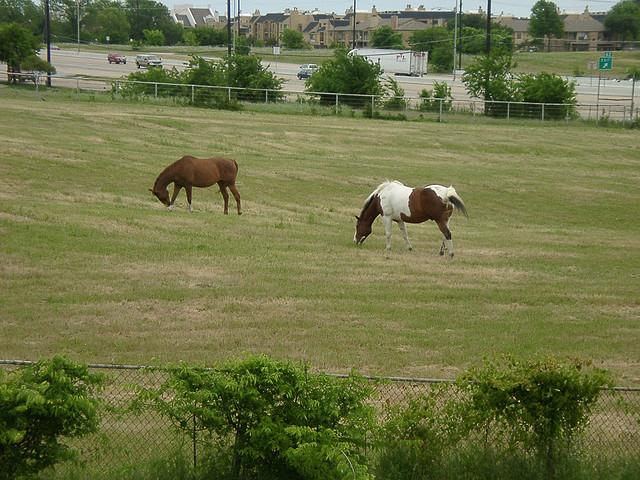Are there ducks here?
Keep it brief. No. What color is the smaller animal in the picture?
Quick response, please. Brown. What kind of animal is on the right?
Quick response, please. Horse. Are there horses?
Keep it brief. Yes. Which horse runs faster?
Be succinct. Brown. 